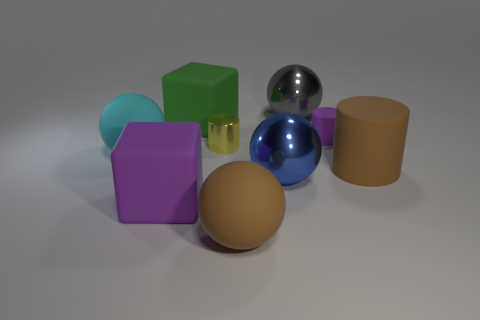Add 1 big matte spheres. How many objects exist? 10 Subtract all large brown rubber balls. How many balls are left? 3 Subtract all cyan balls. How many balls are left? 3 Subtract all cylinders. How many objects are left? 6 Subtract all yellow shiny cylinders. Subtract all big purple blocks. How many objects are left? 7 Add 1 cyan rubber things. How many cyan rubber things are left? 2 Add 2 large shiny objects. How many large shiny objects exist? 4 Subtract 0 red cylinders. How many objects are left? 9 Subtract all gray cylinders. Subtract all green blocks. How many cylinders are left? 3 